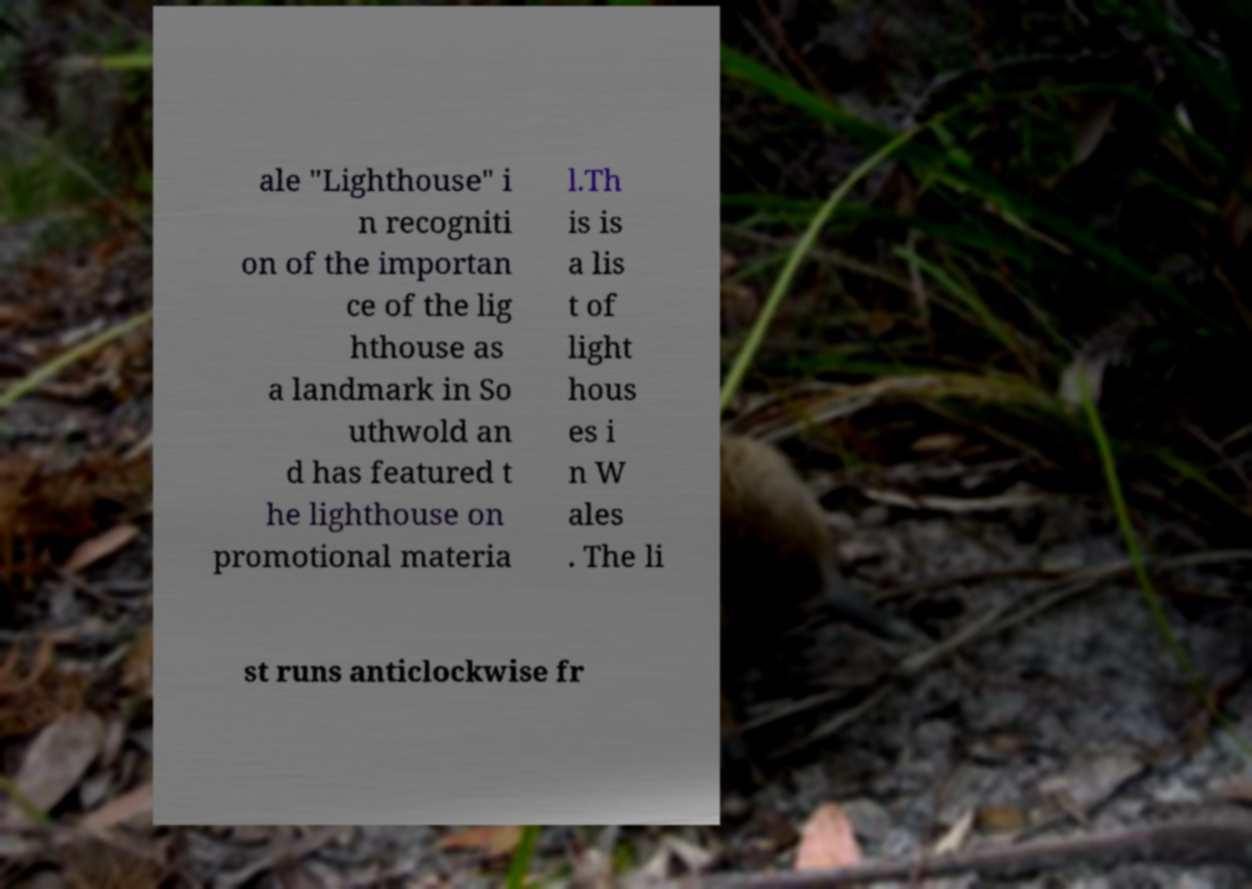Please identify and transcribe the text found in this image. ale "Lighthouse" i n recogniti on of the importan ce of the lig hthouse as a landmark in So uthwold an d has featured t he lighthouse on promotional materia l.Th is is a lis t of light hous es i n W ales . The li st runs anticlockwise fr 